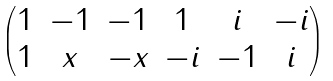Convert formula to latex. <formula><loc_0><loc_0><loc_500><loc_500>\begin{pmatrix} 1 & - 1 & - 1 & 1 & i & - i \\ 1 & x & - x & - i & - 1 & i \end{pmatrix}</formula> 